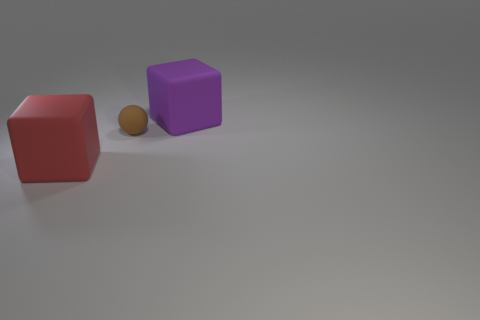Subtract all red balls. Subtract all blue cylinders. How many balls are left? 1 Add 1 purple cubes. How many objects exist? 4 Subtract all spheres. How many objects are left? 2 Subtract all big yellow metal cylinders. Subtract all matte spheres. How many objects are left? 2 Add 1 large red rubber cubes. How many large red rubber cubes are left? 2 Add 1 tiny brown balls. How many tiny brown balls exist? 2 Subtract 0 blue balls. How many objects are left? 3 